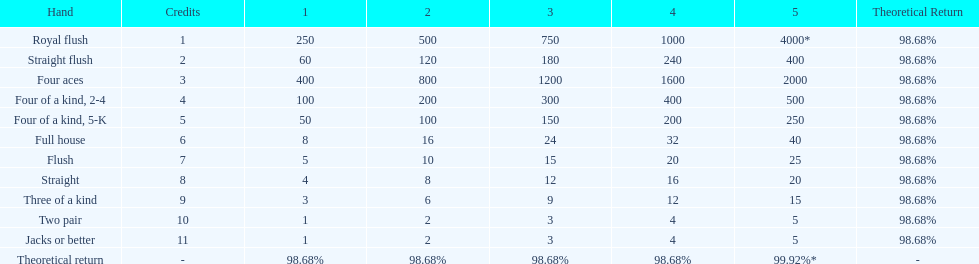Is four 5s worth more or less than four 2s? Less. 